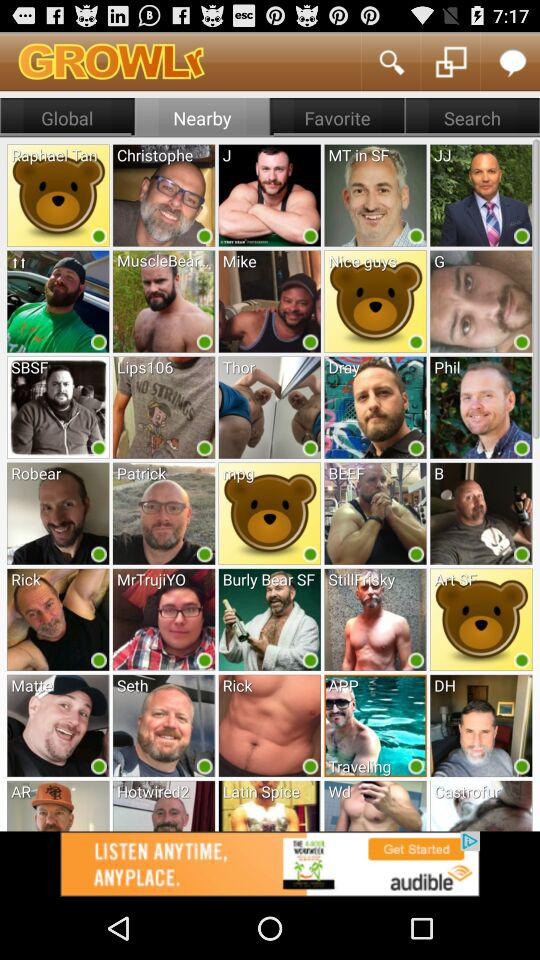How many people are saved in "Favorite"?
When the provided information is insufficient, respond with <no answer>. <no answer> 